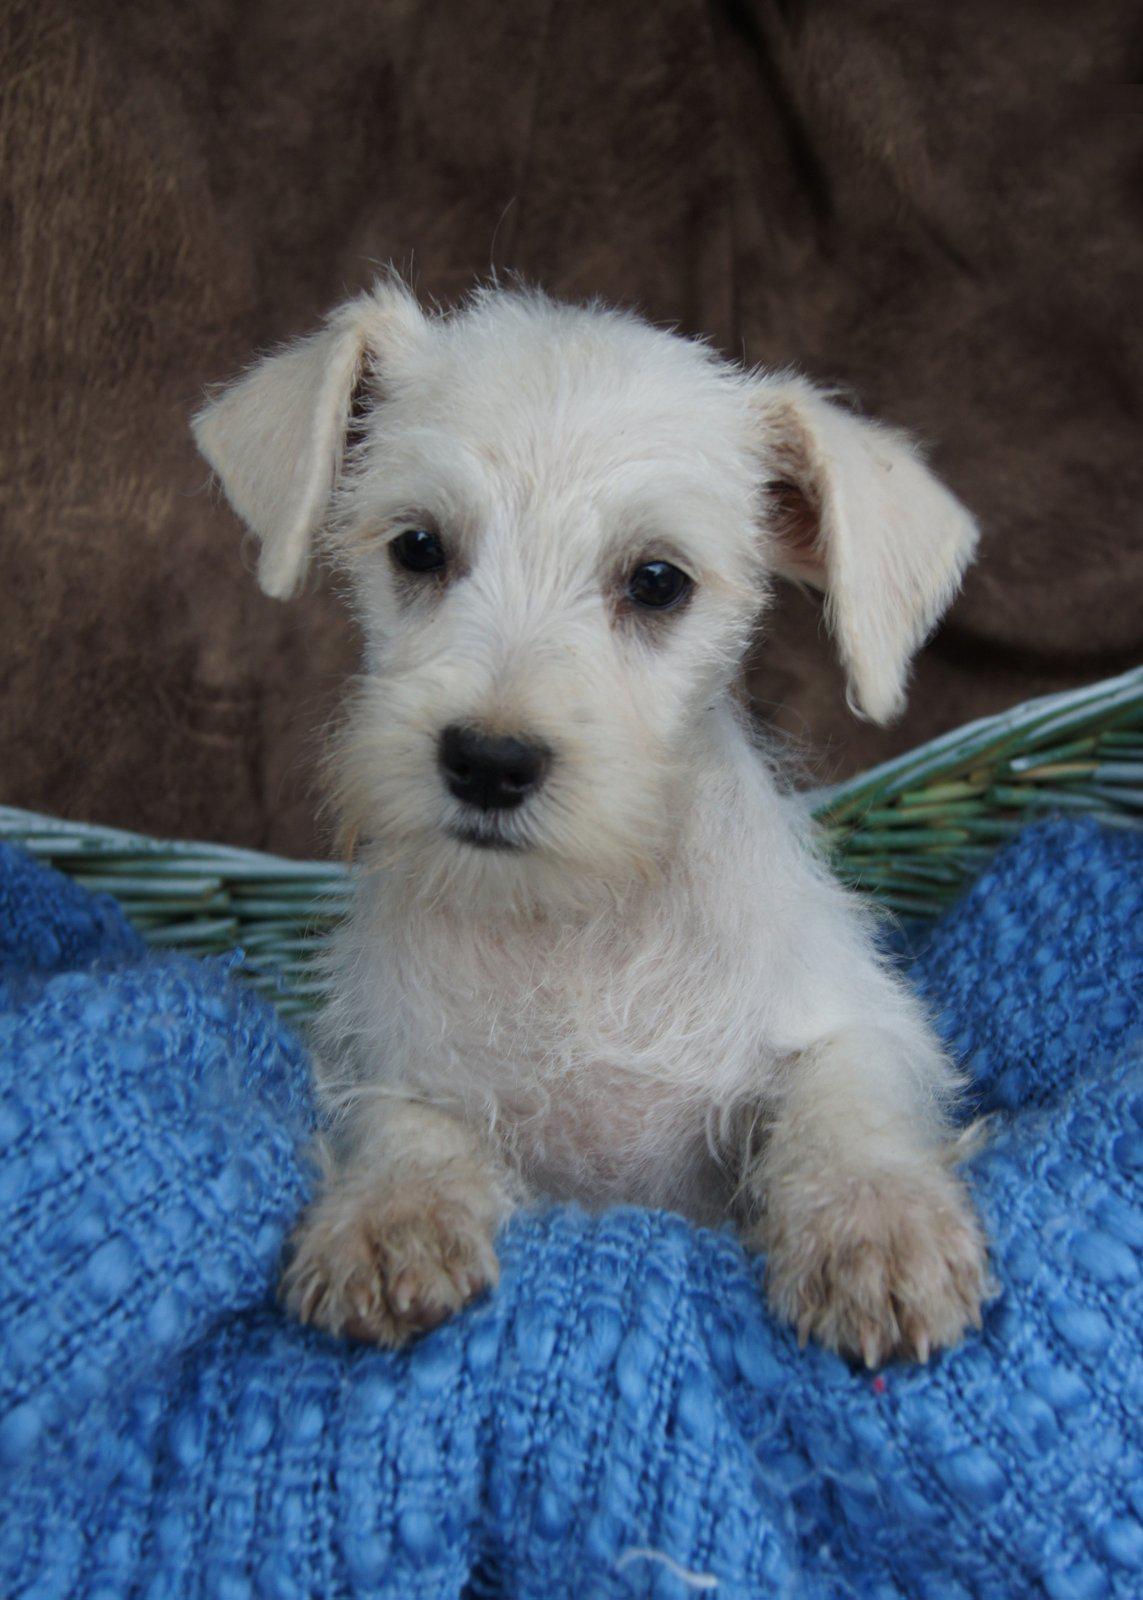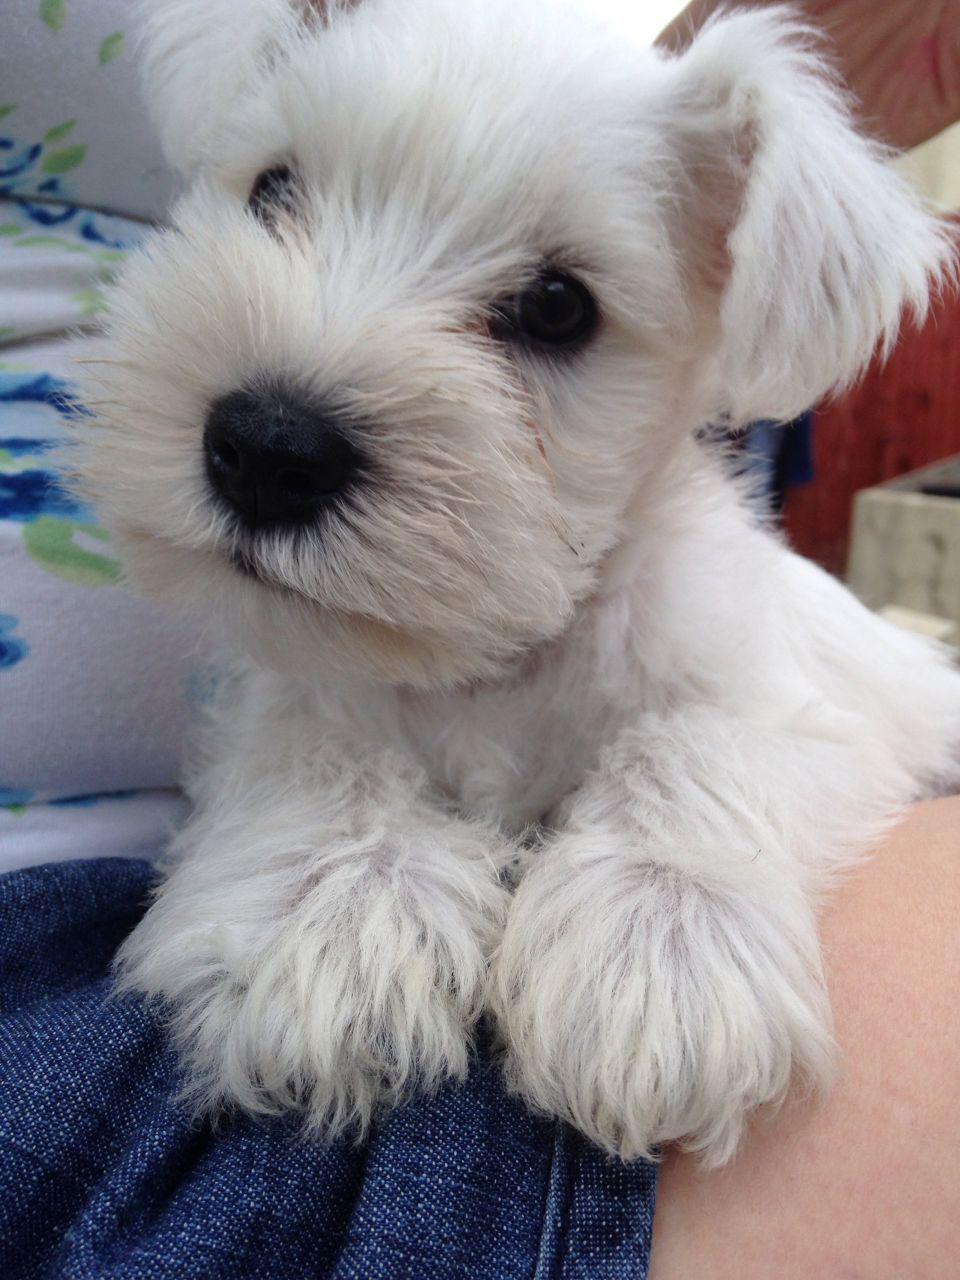The first image is the image on the left, the second image is the image on the right. Analyze the images presented: Is the assertion "Each image contains one white dog, and the dog on the right is posed by striped fabric." valid? Answer yes or no. No. The first image is the image on the left, the second image is the image on the right. Evaluate the accuracy of this statement regarding the images: "The image on the left is either of a group of puppies huddled together or of a single white dog wearing a red collar.". Is it true? Answer yes or no. No. 